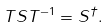<formula> <loc_0><loc_0><loc_500><loc_500>T S T ^ { - 1 } = S ^ { \dagger } .</formula> 